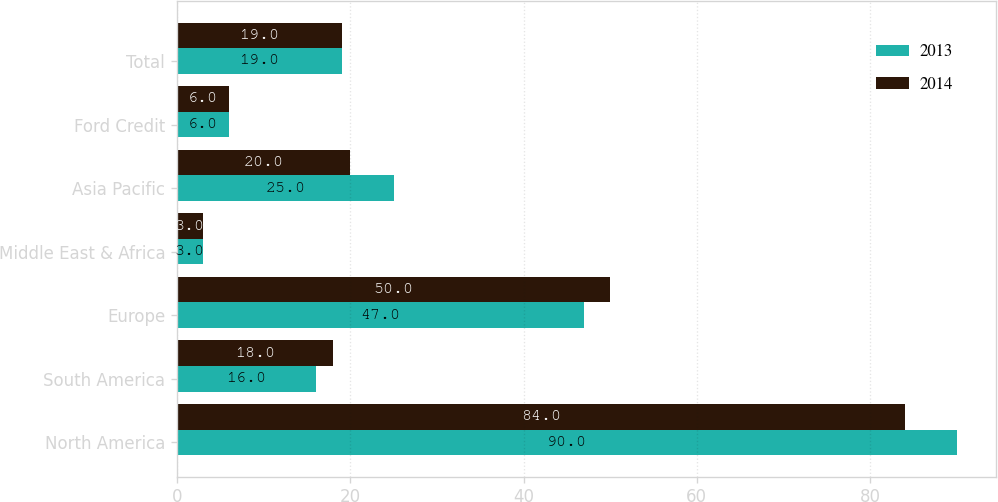Convert chart to OTSL. <chart><loc_0><loc_0><loc_500><loc_500><stacked_bar_chart><ecel><fcel>North America<fcel>South America<fcel>Europe<fcel>Middle East & Africa<fcel>Asia Pacific<fcel>Ford Credit<fcel>Total<nl><fcel>2013<fcel>90<fcel>16<fcel>47<fcel>3<fcel>25<fcel>6<fcel>19<nl><fcel>2014<fcel>84<fcel>18<fcel>50<fcel>3<fcel>20<fcel>6<fcel>19<nl></chart> 